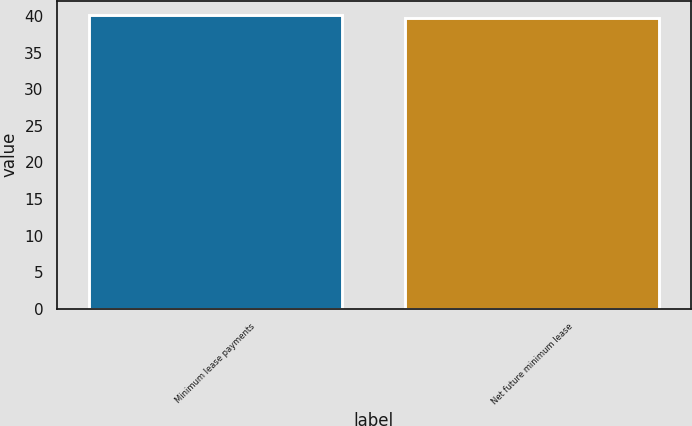Convert chart to OTSL. <chart><loc_0><loc_0><loc_500><loc_500><bar_chart><fcel>Minimum lease payments<fcel>Net future minimum lease<nl><fcel>40.1<fcel>39.7<nl></chart> 